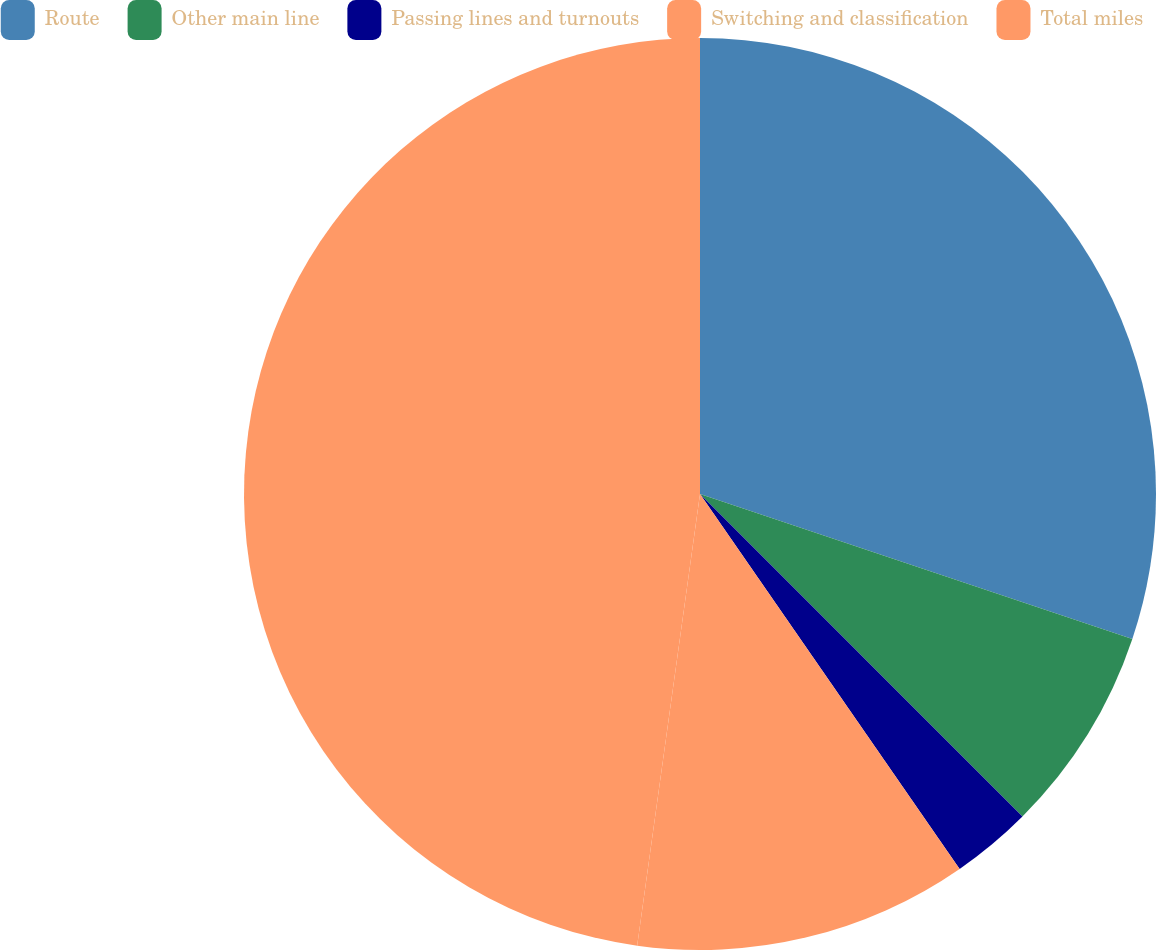Convert chart to OTSL. <chart><loc_0><loc_0><loc_500><loc_500><pie_chart><fcel>Route<fcel>Other main line<fcel>Passing lines and turnouts<fcel>Switching and classification<fcel>Total miles<nl><fcel>30.15%<fcel>7.35%<fcel>2.86%<fcel>11.84%<fcel>47.8%<nl></chart> 